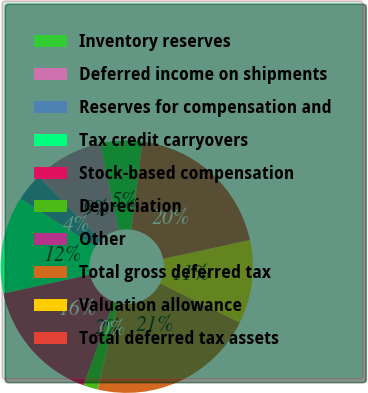Convert chart to OTSL. <chart><loc_0><loc_0><loc_500><loc_500><pie_chart><fcel>Inventory reserves<fcel>Deferred income on shipments<fcel>Reserves for compensation and<fcel>Tax credit carryovers<fcel>Stock-based compensation<fcel>Depreciation<fcel>Other<fcel>Total gross deferred tax<fcel>Valuation allowance<fcel>Total deferred tax assets<nl><fcel>5.38%<fcel>8.93%<fcel>3.6%<fcel>12.49%<fcel>16.04%<fcel>1.83%<fcel>0.05%<fcel>21.37%<fcel>10.71%<fcel>19.6%<nl></chart> 